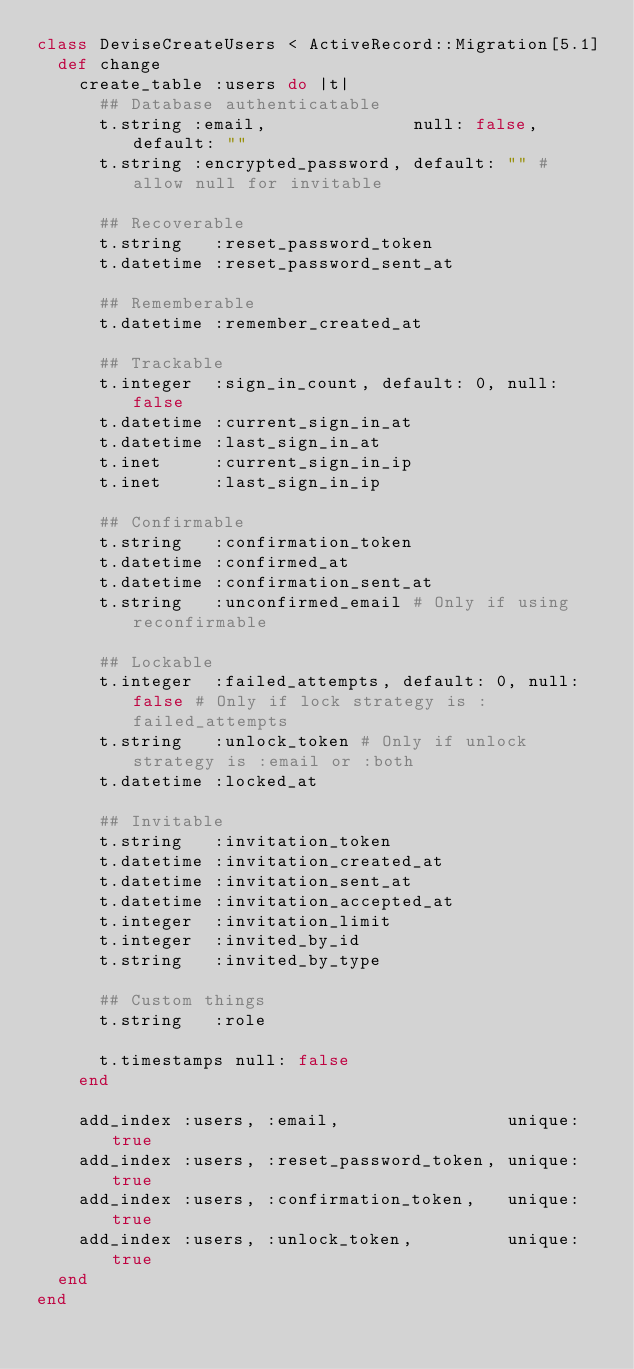Convert code to text. <code><loc_0><loc_0><loc_500><loc_500><_Ruby_>class DeviseCreateUsers < ActiveRecord::Migration[5.1]
  def change
    create_table :users do |t|
      ## Database authenticatable
      t.string :email,              null: false, default: ""
      t.string :encrypted_password, default: "" # allow null for invitable

      ## Recoverable
      t.string   :reset_password_token
      t.datetime :reset_password_sent_at

      ## Rememberable
      t.datetime :remember_created_at

      ## Trackable
      t.integer  :sign_in_count, default: 0, null: false
      t.datetime :current_sign_in_at
      t.datetime :last_sign_in_at
      t.inet     :current_sign_in_ip
      t.inet     :last_sign_in_ip

      ## Confirmable
      t.string   :confirmation_token
      t.datetime :confirmed_at
      t.datetime :confirmation_sent_at
      t.string   :unconfirmed_email # Only if using reconfirmable

      ## Lockable
      t.integer  :failed_attempts, default: 0, null: false # Only if lock strategy is :failed_attempts
      t.string   :unlock_token # Only if unlock strategy is :email or :both
      t.datetime :locked_at

      ## Invitable
      t.string   :invitation_token
      t.datetime :invitation_created_at
      t.datetime :invitation_sent_at
      t.datetime :invitation_accepted_at
      t.integer  :invitation_limit
      t.integer  :invited_by_id
      t.string   :invited_by_type

      ## Custom things
      t.string   :role

      t.timestamps null: false
    end

    add_index :users, :email,                unique: true
    add_index :users, :reset_password_token, unique: true
    add_index :users, :confirmation_token,   unique: true
    add_index :users, :unlock_token,         unique: true
  end
end
</code> 